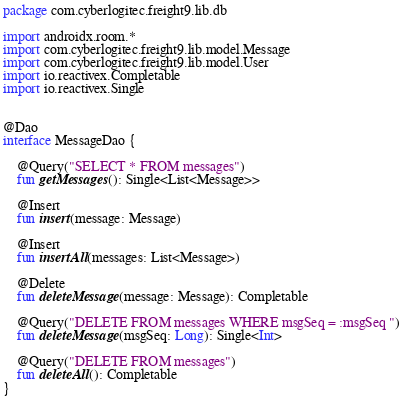<code> <loc_0><loc_0><loc_500><loc_500><_Kotlin_>package com.cyberlogitec.freight9.lib.db

import androidx.room.*
import com.cyberlogitec.freight9.lib.model.Message
import com.cyberlogitec.freight9.lib.model.User
import io.reactivex.Completable
import io.reactivex.Single


@Dao
interface MessageDao {

    @Query("SELECT * FROM messages")
    fun getMessages(): Single<List<Message>>

    @Insert
    fun insert(message: Message)

    @Insert
    fun insertAll(messages: List<Message>)

    @Delete
    fun deleteMessage(message: Message): Completable

    @Query("DELETE FROM messages WHERE msgSeq = :msgSeq ")
    fun deleteMessage(msgSeq: Long): Single<Int>

    @Query("DELETE FROM messages")
    fun deleteAll(): Completable
}</code> 